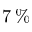Convert formula to latex. <formula><loc_0><loc_0><loc_500><loc_500>7 \, \%</formula> 